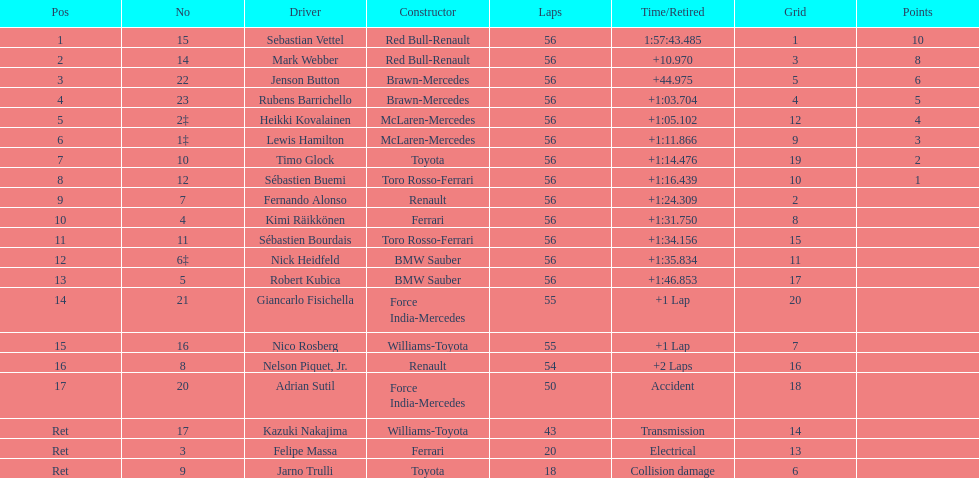Who finished the race with the slowest time? Robert Kubica. 